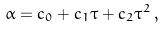<formula> <loc_0><loc_0><loc_500><loc_500>\alpha = c _ { 0 } + c _ { 1 } \tau + c _ { 2 } \tau ^ { 2 } \, ,</formula> 